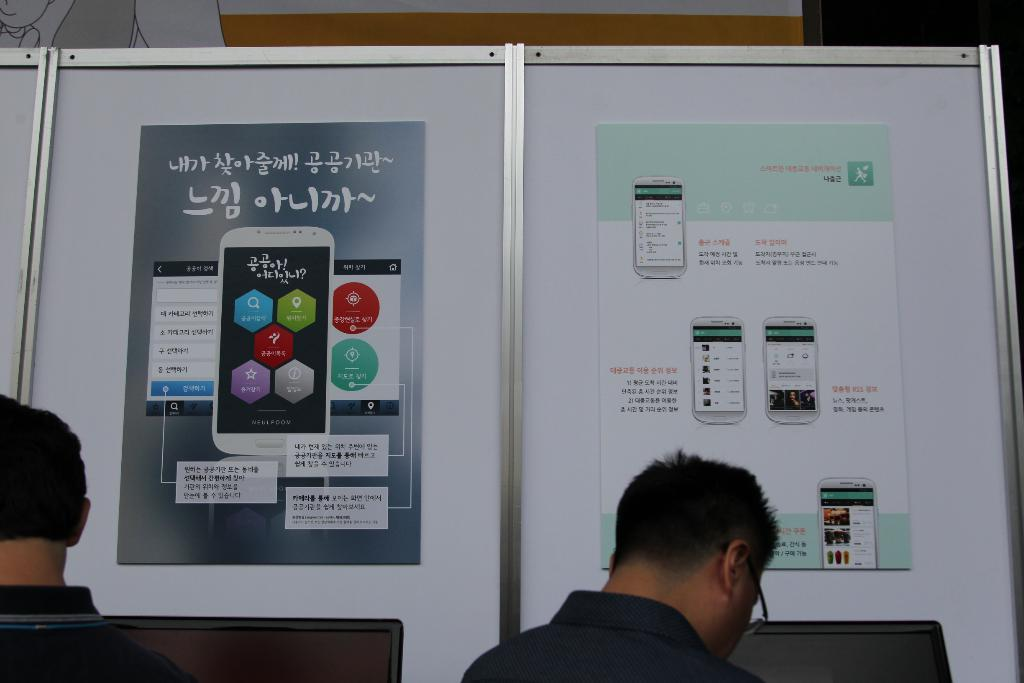How many people are in the image? There are two persons in the image. What are the persons doing in the image? The persons are standing in front of a board. What is on the board? There are two posters on the board. Can you describe one of the persons in the image? One person is wearing spectacles. What type of cheese can be seen on the board in the image? There is no cheese present on the board or in the image. 